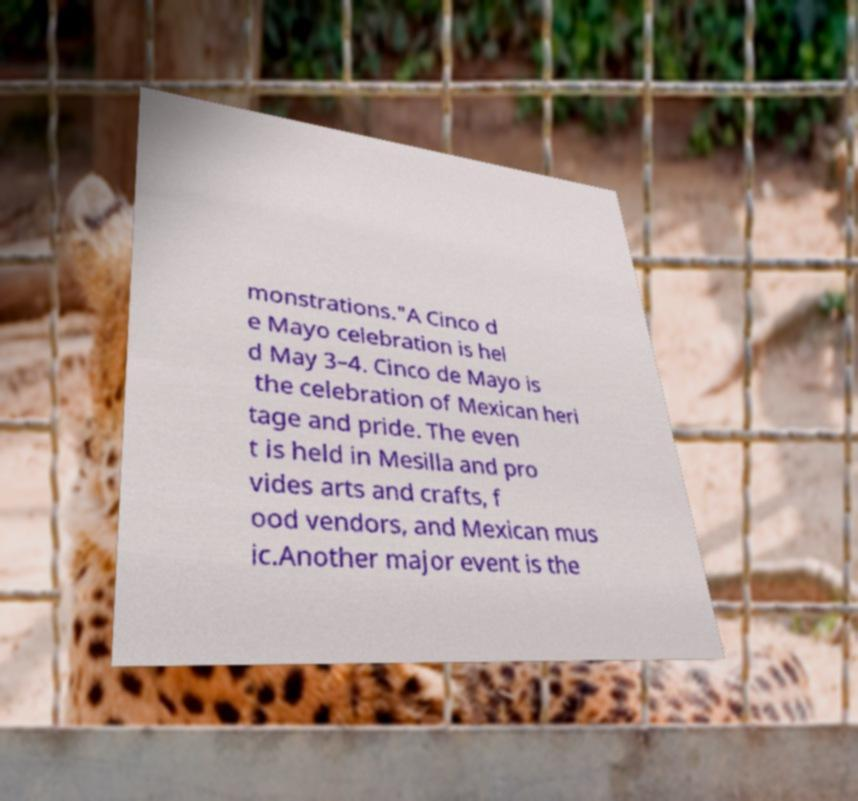Could you assist in decoding the text presented in this image and type it out clearly? monstrations."A Cinco d e Mayo celebration is hel d May 3–4. Cinco de Mayo is the celebration of Mexican heri tage and pride. The even t is held in Mesilla and pro vides arts and crafts, f ood vendors, and Mexican mus ic.Another major event is the 